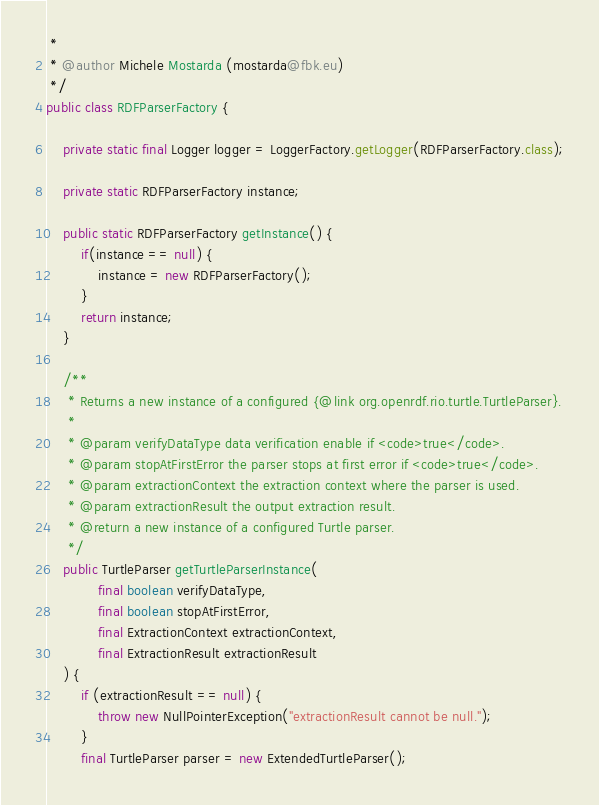<code> <loc_0><loc_0><loc_500><loc_500><_Java_> *
 * @author Michele Mostarda (mostarda@fbk.eu)
 */
public class RDFParserFactory {

    private static final Logger logger = LoggerFactory.getLogger(RDFParserFactory.class);

    private static RDFParserFactory instance;

    public static RDFParserFactory getInstance() {
        if(instance == null) {
            instance = new RDFParserFactory();
        }
        return instance;
    }

    /**
     * Returns a new instance of a configured {@link org.openrdf.rio.turtle.TurtleParser}.
     *
     * @param verifyDataType data verification enable if <code>true</code>.
     * @param stopAtFirstError the parser stops at first error if <code>true</code>.
     * @param extractionContext the extraction context where the parser is used.
     * @param extractionResult the output extraction result.
     * @return a new instance of a configured Turtle parser.
     */
    public TurtleParser getTurtleParserInstance(
            final boolean verifyDataType,
            final boolean stopAtFirstError,
            final ExtractionContext extractionContext,
            final ExtractionResult extractionResult
    ) {
        if (extractionResult == null) {
            throw new NullPointerException("extractionResult cannot be null.");
        }
        final TurtleParser parser = new ExtendedTurtleParser();</code> 